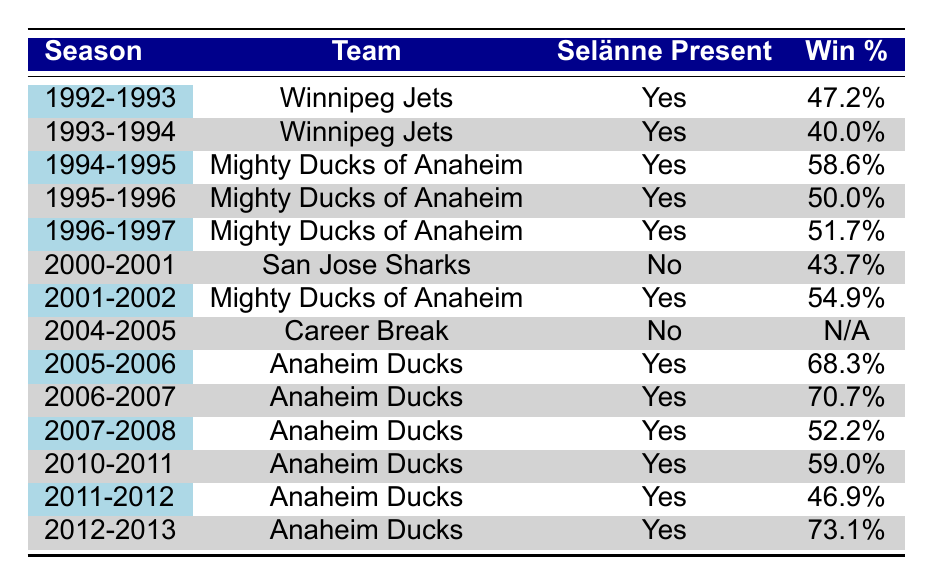What was the win percentage for the team in the 1994-1995 season? Referring to the table, in the 1994-1995 season, the team is the Mighty Ducks of Anaheim, and the win percentage is listed as 58.6%.
Answer: 58.6% Did the Anaheim Ducks have a higher win percentage in 2006-2007 or 2010-2011? By checking the table, the Anaheim Ducks' win percentage in 2006-2007 is 70.7%, while in 2010-2011, it is 59.0%. Since 70.7% is greater than 59.0%, the Ducks had a higher win percentage in 2006-2007.
Answer: 2006-2007 How many seasons did Teemu Selanne play for the Mighty Ducks of Anaheim? Looking at the table, we see the seasons 1994-1995, 1995-1996, 1996-1997, 2001-2002, 2005-2006, 2006-2007, 2007-2008, 2010-2011, 2011-2012, and 2012-2013, which totals to 9 seasons.
Answer: 9 What is the average win percentage for seasons when Selanne was present? To find the average, we first sum the win percentages from the rows where Selanne is present: 47.2, 40.0, 58.6, 50.0, 51.7, 54.9, 68.3, 70.7, 52.2, 59.0, 46.9, and 73.1. The sum is 37.3%. The number of seasons is 11. Therefore, the average is 54.2% (sum/number of seasons).
Answer: 54.2% Was Selanne absent in the 2000-2001 season? Referring to the table, in the 2000-2001 season, the data indicates "No" for Selanne's presence, confirming that he was absent that season.
Answer: Yes Which team had the highest win percentage with Selanne on the roster? From the table, we can see that the highest win percentage when Selanne was present was 73.1% in the 2012-2013 season with the Anaheim Ducks.
Answer: Anaheim Ducks, 73.1% What difference in win percentage exists between Selanne's presence and absence in the 2000-2001 season? The win percentage when Selanne was present in 2000-2001 is not applicable (as he was absent), which is 0%. The win percentage for that season with no Selanne present is 43.7%. The difference is thus 43.7%.
Answer: 43.7% In how many seasons did Selanne contribute to a win percentage above 60%? By analyzing the table, the seasons with win percentages above 60% are 2005-2006 (68.3%), 2006-2007 (70.7%), and 2012-2013 (73.1%). This results in a total of 3 seasons.
Answer: 3 